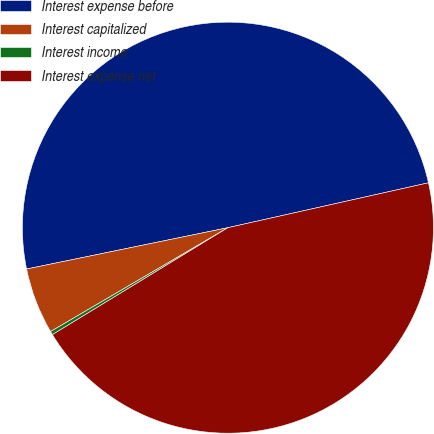Convert chart to OTSL. <chart><loc_0><loc_0><loc_500><loc_500><pie_chart><fcel>Interest expense before<fcel>Interest capitalized<fcel>Interest income<fcel>Interest expense net<nl><fcel>49.72%<fcel>5.21%<fcel>0.28%<fcel>44.79%<nl></chart> 